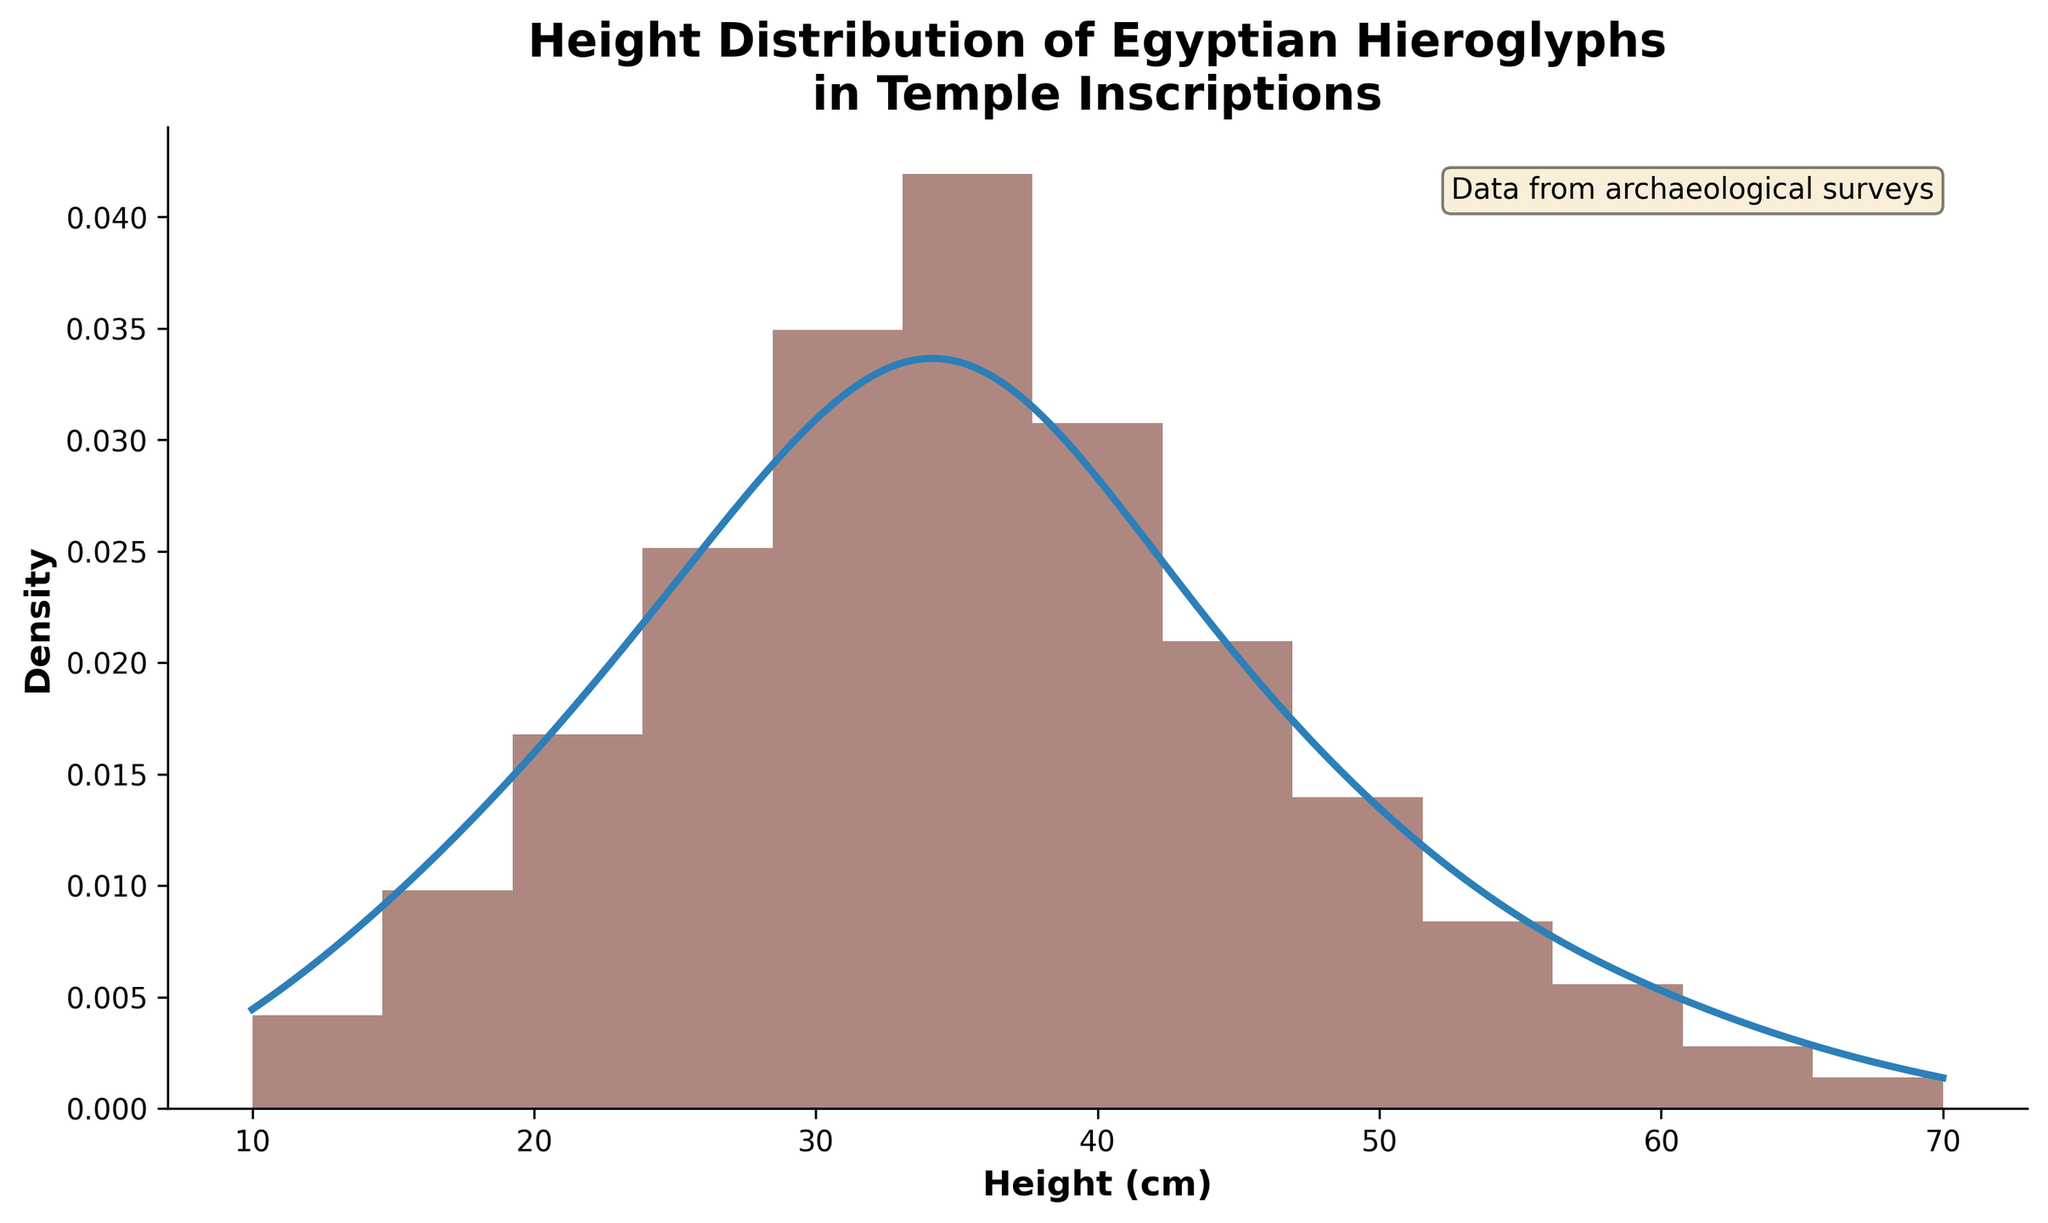What is the title of the histogram? The title of the histogram is shown at the top of the figure. It reads "Height Distribution of Egyptian Hieroglyphs in Temple Inscriptions".
Answer: Height Distribution of Egyptian Hieroglyphs in Temple Inscriptions What is the height range for the histogram? To find the height range, look at the x-axis which starts at 10 cm and ends at 70 cm. This shows the extent of the data range.
Answer: 10 cm to 70 cm What height has the highest frequency of hieroglyphs? Observe the tallest bar in the histogram. The tallest bar is centered around 35 cm, which indicates the highest frequency.
Answer: 35 cm How does the KDE curve compare in shape to the histogram bars? The KDE curve represents a smoothed version of the histogram bars. It generally follows the same pattern of peaks and troughs but with a smoother transition between heights.
Answer: The KDE curve smoothly follows the histogram peaks and troughs How many bins are used in the histogram? Count the number of distinct vertical bars in the histogram. There are 13 bins represented.
Answer: 13 What is the total frequency of hieroglyphs for heights 30 cm and taller? Sum the frequencies for heights starting at 30 cm up to 70 cm. The frequencies are 25 + 30 + 22 + 15 + 10 + 6 + 4 + 2 + 1 = 115.
Answer: 115 Which height has the least frequent hieroglyphs? Identify the shortest bar in the histogram. The shortest bar is at 70 cm, indicating it has the least frequency.
Answer: 70 cm What can you infer about the most common height range of hieroglyphs based on the KDE peak? The KDE peak is around 35 cm, showing that the most common height range for hieroglyphs is near this value. This aligns with the largest histogram bar.
Answer: Around 35 cm Compare the frequency of hieroglyphs at 20 cm and 50 cm. Which is higher? The bar at 20 cm is taller compared to the bar at 50 cm. Therefore, the frequency of hieroglyphs at 20 cm is higher.
Answer: 20 cm What is the density value at 40 cm on the KDE curve? Locate the position of 40 cm on the x-axis and trace upwards to intersect with the KDE curve. At the intersection, observe the density value on the y-axis, which appears to be around 0.025.
Answer: Approximately 0.025 